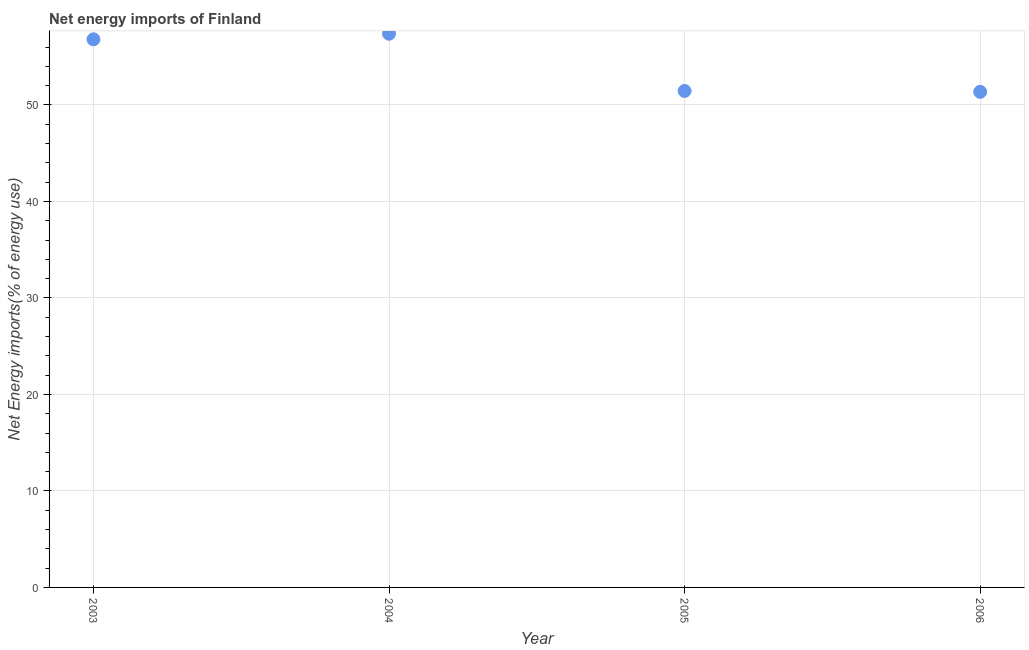What is the energy imports in 2006?
Your answer should be very brief. 51.36. Across all years, what is the maximum energy imports?
Offer a terse response. 57.38. Across all years, what is the minimum energy imports?
Make the answer very short. 51.36. In which year was the energy imports maximum?
Provide a succinct answer. 2004. What is the sum of the energy imports?
Ensure brevity in your answer.  217. What is the difference between the energy imports in 2005 and 2006?
Offer a terse response. 0.09. What is the average energy imports per year?
Your response must be concise. 54.25. What is the median energy imports?
Your answer should be very brief. 54.13. Do a majority of the years between 2004 and 2003 (inclusive) have energy imports greater than 34 %?
Keep it short and to the point. No. What is the ratio of the energy imports in 2003 to that in 2004?
Offer a very short reply. 0.99. Is the energy imports in 2004 less than that in 2005?
Offer a terse response. No. Is the difference between the energy imports in 2004 and 2005 greater than the difference between any two years?
Your answer should be compact. No. What is the difference between the highest and the second highest energy imports?
Provide a short and direct response. 0.58. Is the sum of the energy imports in 2005 and 2006 greater than the maximum energy imports across all years?
Provide a short and direct response. Yes. What is the difference between the highest and the lowest energy imports?
Ensure brevity in your answer.  6.02. Does the energy imports monotonically increase over the years?
Provide a succinct answer. No. What is the difference between two consecutive major ticks on the Y-axis?
Make the answer very short. 10. Does the graph contain grids?
Ensure brevity in your answer.  Yes. What is the title of the graph?
Provide a succinct answer. Net energy imports of Finland. What is the label or title of the X-axis?
Provide a short and direct response. Year. What is the label or title of the Y-axis?
Provide a succinct answer. Net Energy imports(% of energy use). What is the Net Energy imports(% of energy use) in 2003?
Ensure brevity in your answer.  56.8. What is the Net Energy imports(% of energy use) in 2004?
Ensure brevity in your answer.  57.38. What is the Net Energy imports(% of energy use) in 2005?
Offer a very short reply. 51.45. What is the Net Energy imports(% of energy use) in 2006?
Your answer should be very brief. 51.36. What is the difference between the Net Energy imports(% of energy use) in 2003 and 2004?
Provide a short and direct response. -0.58. What is the difference between the Net Energy imports(% of energy use) in 2003 and 2005?
Provide a succinct answer. 5.35. What is the difference between the Net Energy imports(% of energy use) in 2003 and 2006?
Ensure brevity in your answer.  5.44. What is the difference between the Net Energy imports(% of energy use) in 2004 and 2005?
Give a very brief answer. 5.93. What is the difference between the Net Energy imports(% of energy use) in 2004 and 2006?
Your answer should be compact. 6.02. What is the difference between the Net Energy imports(% of energy use) in 2005 and 2006?
Give a very brief answer. 0.09. What is the ratio of the Net Energy imports(% of energy use) in 2003 to that in 2004?
Offer a terse response. 0.99. What is the ratio of the Net Energy imports(% of energy use) in 2003 to that in 2005?
Provide a succinct answer. 1.1. What is the ratio of the Net Energy imports(% of energy use) in 2003 to that in 2006?
Offer a very short reply. 1.11. What is the ratio of the Net Energy imports(% of energy use) in 2004 to that in 2005?
Keep it short and to the point. 1.11. What is the ratio of the Net Energy imports(% of energy use) in 2004 to that in 2006?
Keep it short and to the point. 1.12. 